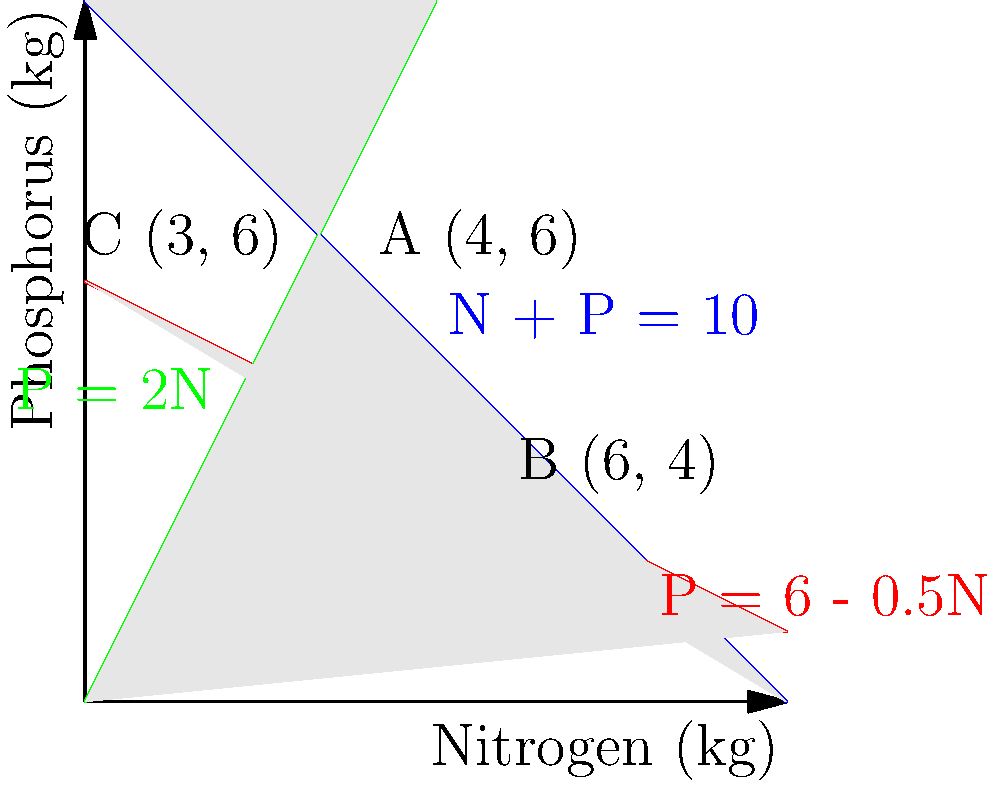In a study on optimal resource allocation for plant growth, you're using linear programming to determine the best combination of nitrogen (N) and phosphorus (P) fertilizers. The constraints are represented by the following inequalities:

1. $N + P \leq 10$ (total available nutrients)
2. $P \leq 6 - 0.5N$ (soil pH balance)
3. $P \geq 2N$ (minimum phosphorus requirement)

Given the objective function $Z = 3N + 2P$ (where Z represents plant growth), what is the optimal combination of N and P that maximizes plant growth? To solve this linear programming problem, we'll follow these steps:

1. Identify the feasible region:
   The feasible region is the shaded area in the graph that satisfies all constraints.

2. Determine the corner points of the feasible region:
   A (4, 6), B (6, 4), and C (3, 6)

3. Calculate the value of the objective function at each corner point:
   Point A (4, 6): $Z = 3(4) + 2(6) = 12 + 12 = 24$
   Point B (6, 4): $Z = 3(6) + 2(4) = 18 + 8 = 26$
   Point C (3, 6): $Z = 3(3) + 2(6) = 9 + 12 = 21$

4. Choose the point with the maximum Z value:
   Point B (6, 4) gives the maximum value of Z = 26.

Therefore, the optimal combination is 6 kg of nitrogen and 4 kg of phosphorus, which maximizes plant growth with a Z value of 26.
Answer: (6, 4) 